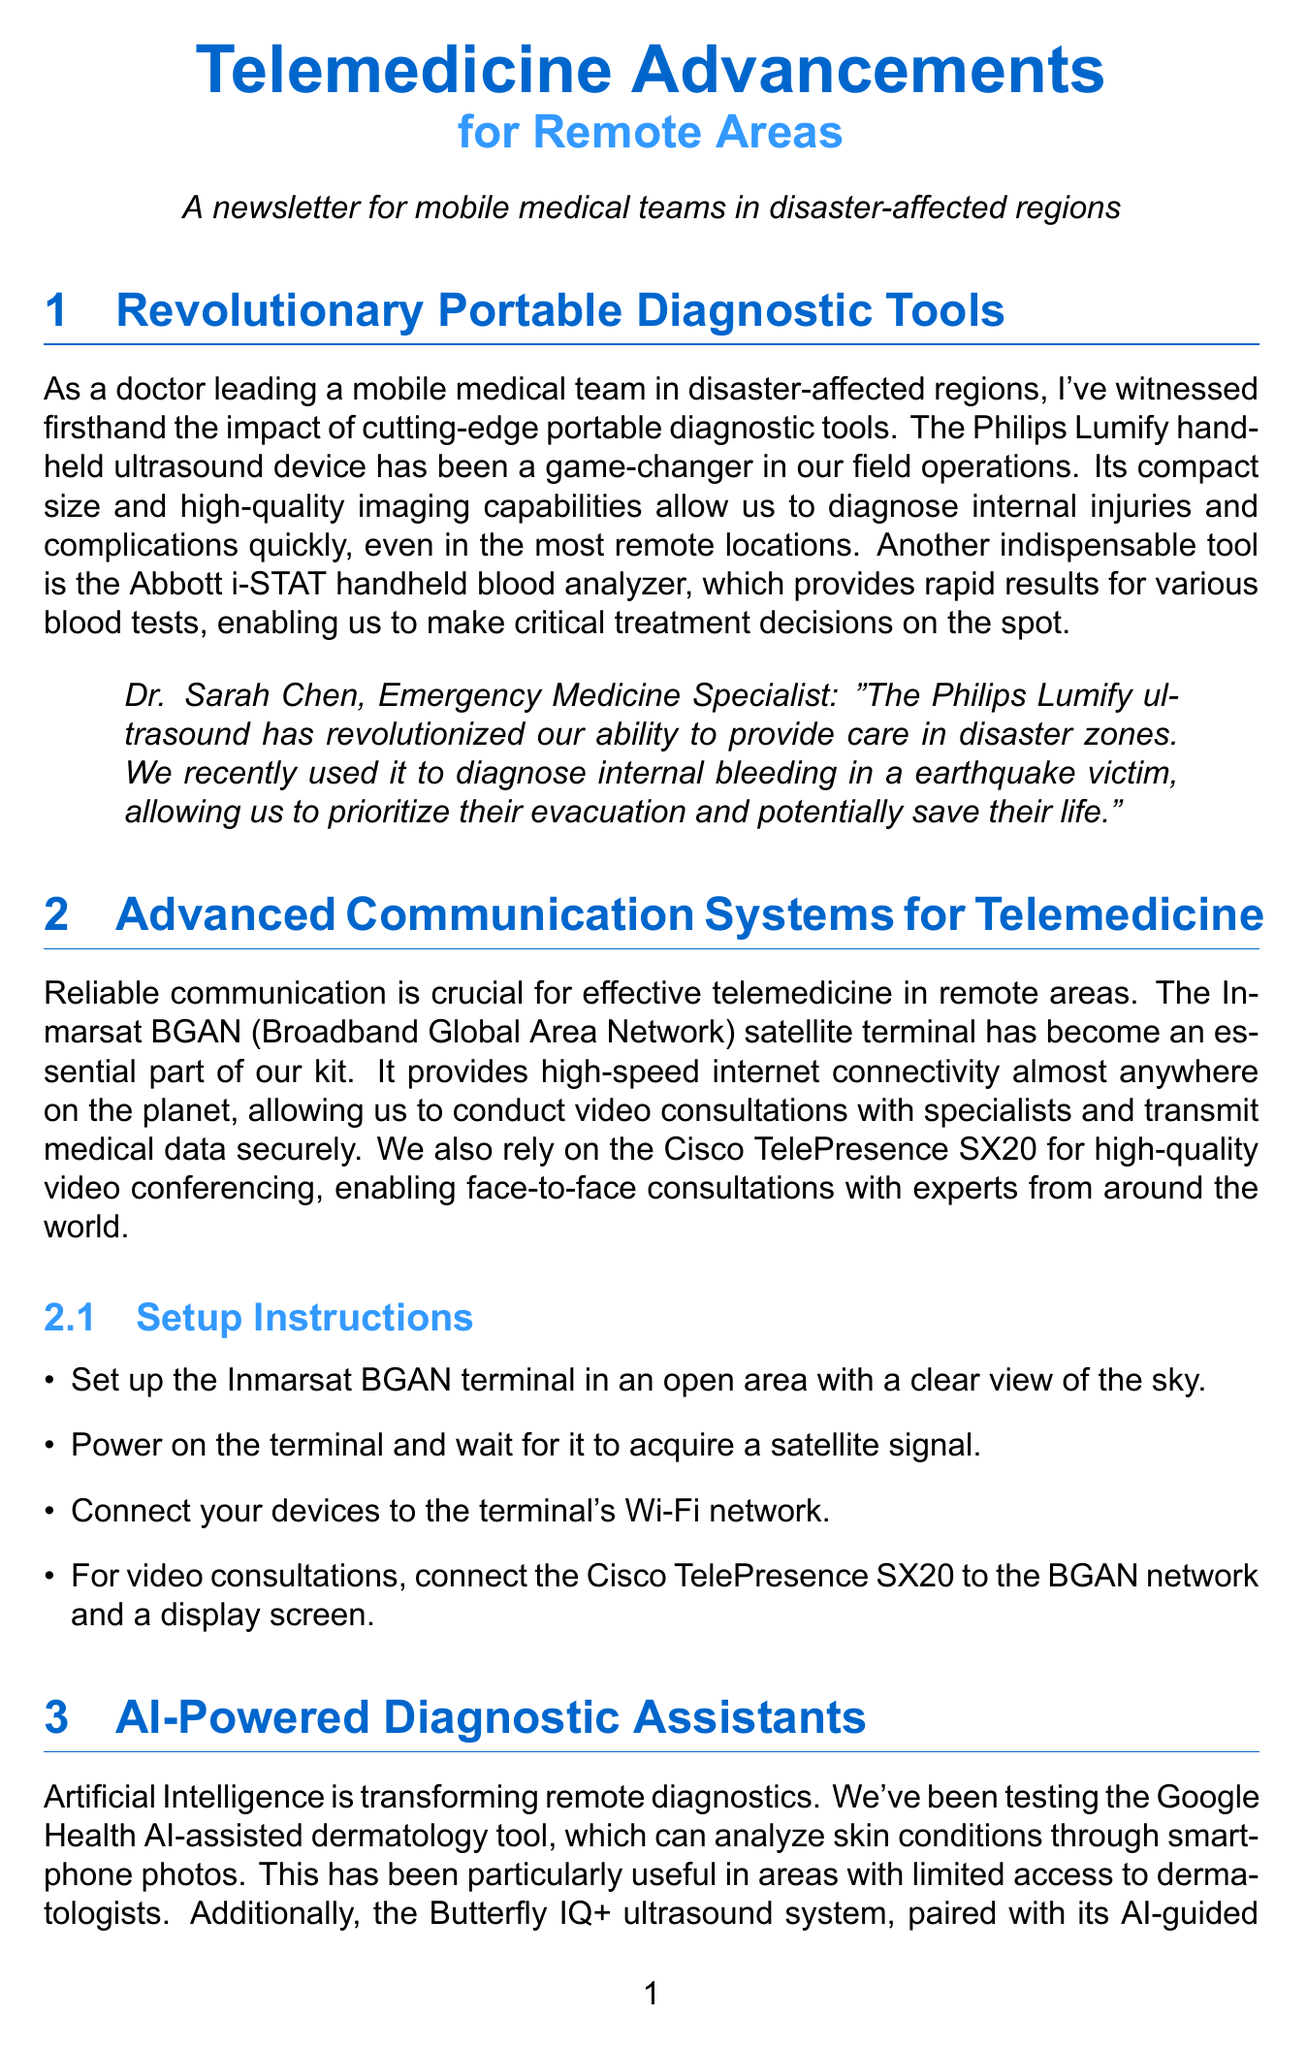What is the title of the newsletter? The newsletter is titled "Telemedicine Advancements for Remote Areas".
Answer: Telemedicine Advancements for Remote Areas Who is the testimonial provided by in relation to the Philips Lumify ultrasound? Dr. Sarah Chen is the Emergency Medicine Specialist who provided a testimonial regarding the Philips Lumify ultrasound.
Answer: Dr. Sarah Chen What tool is used for high-speed internet connectivity? The Inmarsat BGAN satellite terminal is used for high-speed internet connectivity.
Answer: Inmarsat BGAN Which AI tool assists with dermatology? The Google Health AI-assisted dermatology tool is used to analyze skin conditions.
Answer: Google Health AI-assisted dermatology tool What is required to register on the MSF Telemedicine platform? Registering on the MSF Telemedicine platform requires the team's registration, which involves visiting the specified website.
Answer: Register your team on the MSF Telemedicine platform How many setup instructions are provided for the Inmarsat BGAN terminal? There are four setup instructions provided for the Inmarsat BGAN terminal.
Answer: Four What type of communication does the Cisco TelePresence SX20 enable? The Cisco TelePresence SX20 enables high-quality video conferencing.
Answer: High-quality video conferencing What is the main benefit of the Butterfly IQ+ ultrasound system? The main benefit is that it allows team members with minimal training to perform complex ultrasound exams.
Answer: Empowering team members with minimal training What does the WHO EMT platform facilitate? The WHO EMT platform facilitates coordination between different medical teams and local health authorities.
Answer: Coordination between medical teams and local health authorities 